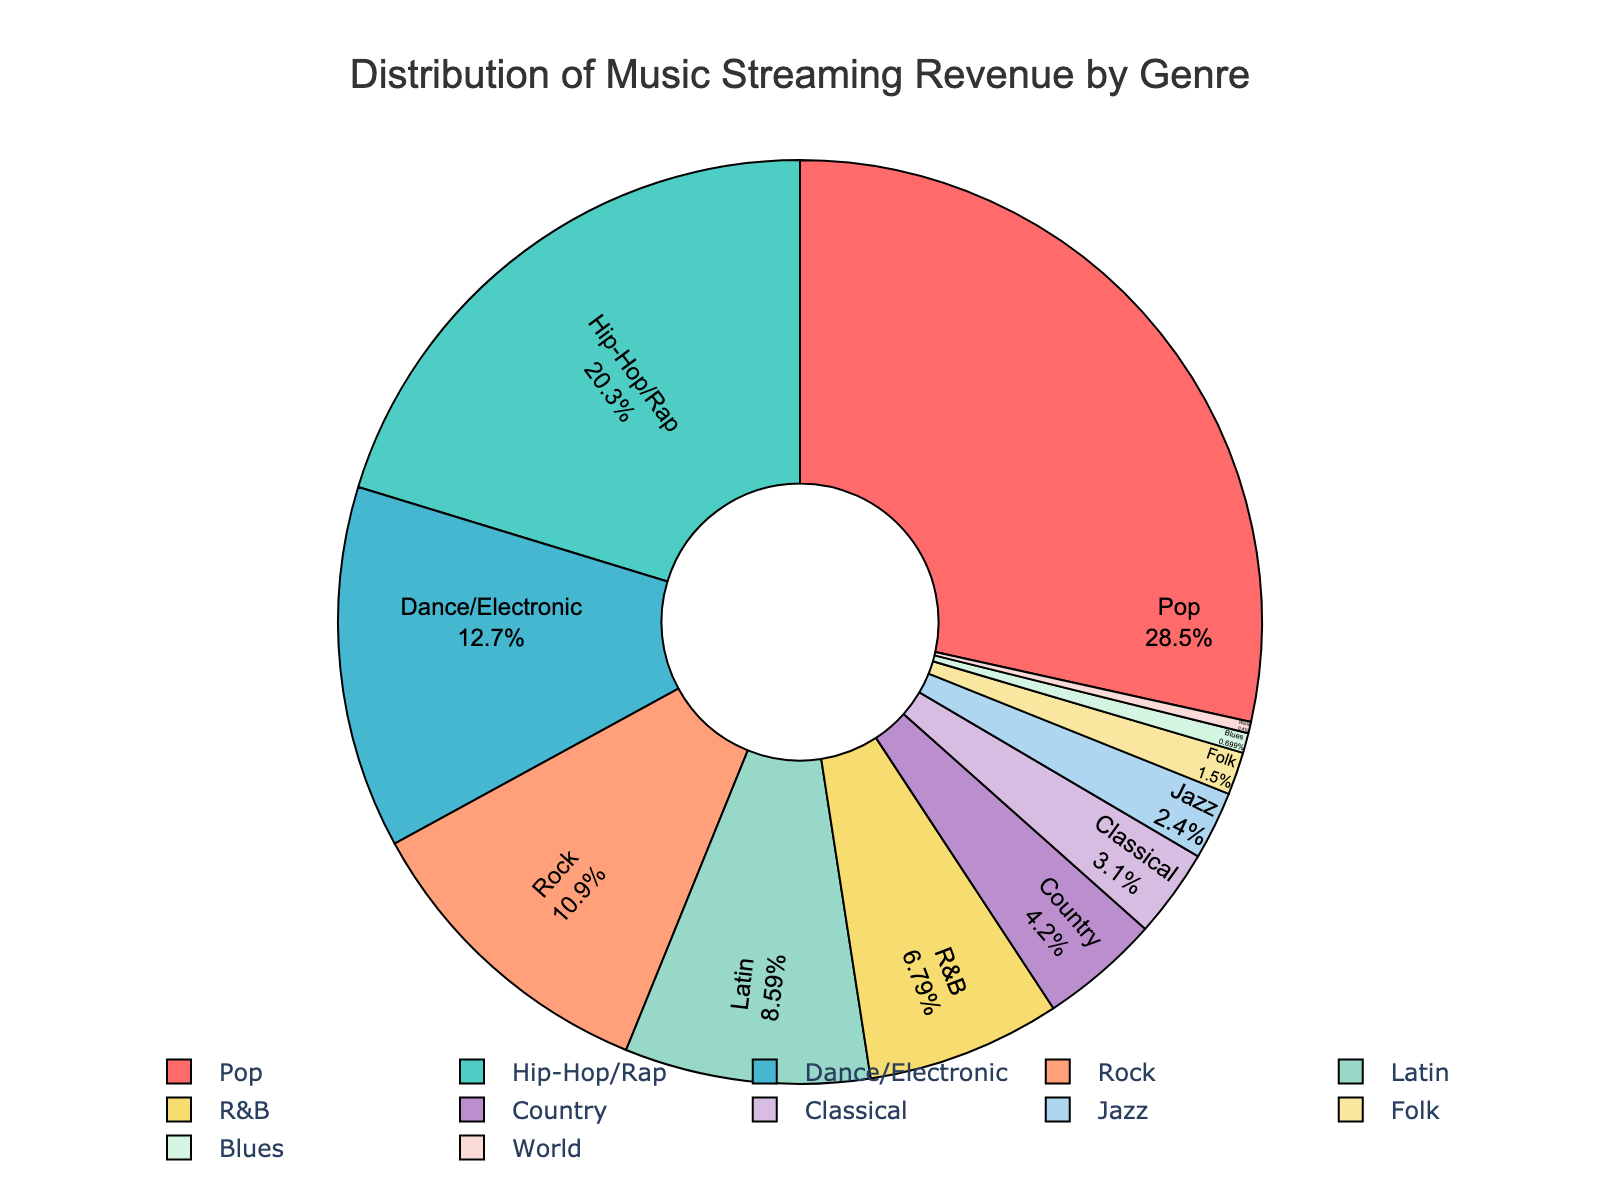What genre has the highest percentage of streaming revenue? The highest percentage in the pie chart is labeled with "Pop" and shows a percentage of 28.5%.
Answer: Pop Which genre has a higher percentage of streaming revenue, Hip-Hop/Rap or Rock? By comparing the percentages in the pie chart, Hip-Hop/Rap has 20.3% whereas Rock has 10.9%. Thus, Hip-Hop/Rap has a higher percentage.
Answer: Hip-Hop/Rap What is the combined percentage of streaming revenue for Classical and Jazz? To find the combined percentage, add the percentages for Classical (3.1%) and Jazz (2.4%). So, 3.1 + 2.4 = 5.5%.
Answer: 5.5% Which genre has the smallest share of streaming revenue and what is that percentage? The smallest segment in the pie chart is labeled "World" with a percentage of 0.4%.
Answer: World with 0.4% Is the percentage of streaming revenue for Latin higher than for R&B? By comparing the percentages, Latin has 8.6% while R&B has 6.8%, so yes, the percentage is higher for Latin.
Answer: Yes Compare the total streaming percentage of genres Pop and Dance/Electronic to Country. Which is higher? The combined percentage for Pop and Dance/Electronic is 28.5 + 12.7 = 41.2%. The percentage for Country alone is 4.2%. Thus, the combination of Pop and Dance/Electronic is higher.
Answer: Pop and Dance/Electronic By how much does the percentage of streaming revenue for Pop exceed that of Latin? Subtract the percentage of Latin (8.6%) from Pop (28.5%). So, 28.5 - 8.6 = 19.9%.
Answer: 19.9% What’s the total percentage for genres with less than 5% streaming revenue each? Summing the percentages of genres with less than 5%: Country (4.2%), Classical (3.1%), Jazz (2.4%), Folk (1.5%), Blues (0.7%), World (0.4%). Total = 4.2 + 3.1 + 2.4 + 1.5 + 0.7 + 0.4 = 12.3%.
Answer: 12.3% Which color represents Rock in the pie chart? Looking at the visual chart attributes, Rock is represented by the color light salmon (#FFA07A).
Answer: Light Salmon 